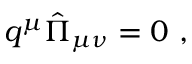<formula> <loc_0><loc_0><loc_500><loc_500>q ^ { \mu } { \hat { \Pi } } _ { \mu \nu } = 0 ,</formula> 